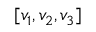<formula> <loc_0><loc_0><loc_500><loc_500>[ v _ { 1 } , v _ { 2 } , v _ { 3 } ]</formula> 